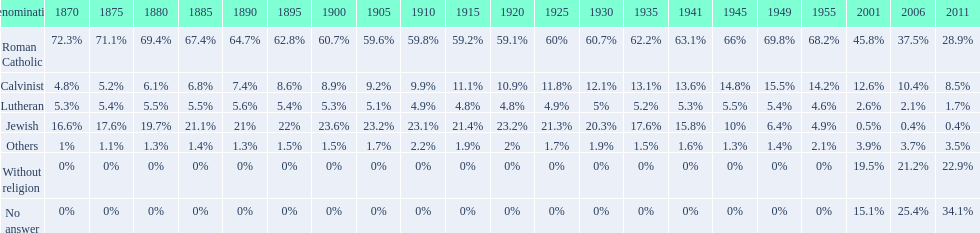Which denomination held the largest percentage in 1880? Roman Catholic. 